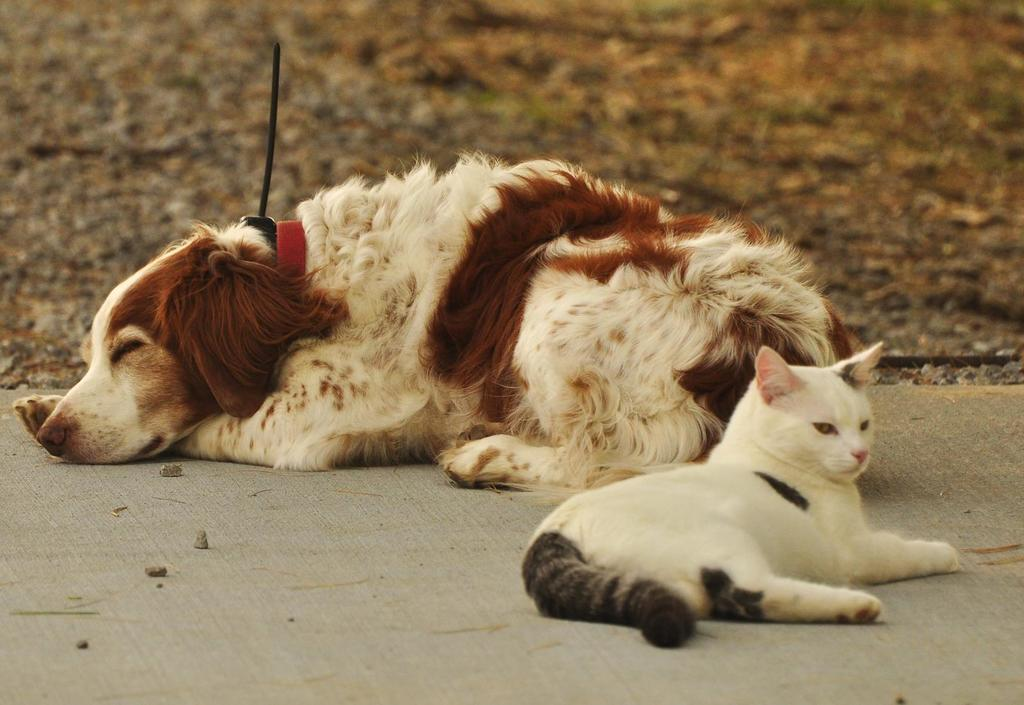What type of animal can be seen in the image? There is a cat and a dog in the image. Can you describe the appearance of the cat? The cat is white and black in color. How about the dog? The dog is brown and cream in color. What can be seen beneath the animals in the image? The ground is visible in the image. What is the quality of the background in the image? The background of the image is blurry. How many apples are on the cat's knee in the image? There are no apples or knees present in the image; it features a cat and a dog. 